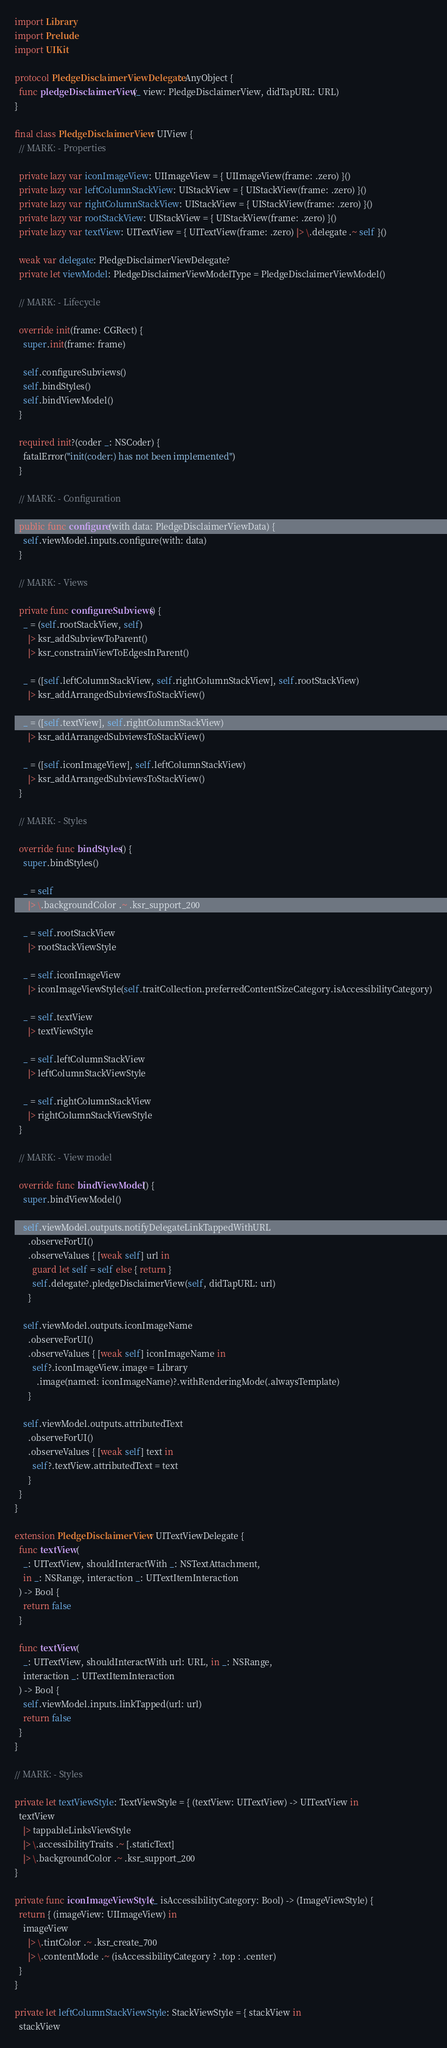<code> <loc_0><loc_0><loc_500><loc_500><_Swift_>import Library
import Prelude
import UIKit

protocol PledgeDisclaimerViewDelegate: AnyObject {
  func pledgeDisclaimerView(_ view: PledgeDisclaimerView, didTapURL: URL)
}

final class PledgeDisclaimerView: UIView {
  // MARK: - Properties

  private lazy var iconImageView: UIImageView = { UIImageView(frame: .zero) }()
  private lazy var leftColumnStackView: UIStackView = { UIStackView(frame: .zero) }()
  private lazy var rightColumnStackView: UIStackView = { UIStackView(frame: .zero) }()
  private lazy var rootStackView: UIStackView = { UIStackView(frame: .zero) }()
  private lazy var textView: UITextView = { UITextView(frame: .zero) |> \.delegate .~ self }()

  weak var delegate: PledgeDisclaimerViewDelegate?
  private let viewModel: PledgeDisclaimerViewModelType = PledgeDisclaimerViewModel()

  // MARK: - Lifecycle

  override init(frame: CGRect) {
    super.init(frame: frame)

    self.configureSubviews()
    self.bindStyles()
    self.bindViewModel()
  }

  required init?(coder _: NSCoder) {
    fatalError("init(coder:) has not been implemented")
  }

  // MARK: - Configuration

  public func configure(with data: PledgeDisclaimerViewData) {
    self.viewModel.inputs.configure(with: data)
  }

  // MARK: - Views

  private func configureSubviews() {
    _ = (self.rootStackView, self)
      |> ksr_addSubviewToParent()
      |> ksr_constrainViewToEdgesInParent()

    _ = ([self.leftColumnStackView, self.rightColumnStackView], self.rootStackView)
      |> ksr_addArrangedSubviewsToStackView()

    _ = ([self.textView], self.rightColumnStackView)
      |> ksr_addArrangedSubviewsToStackView()

    _ = ([self.iconImageView], self.leftColumnStackView)
      |> ksr_addArrangedSubviewsToStackView()
  }

  // MARK: - Styles

  override func bindStyles() {
    super.bindStyles()

    _ = self
      |> \.backgroundColor .~ .ksr_support_200

    _ = self.rootStackView
      |> rootStackViewStyle

    _ = self.iconImageView
      |> iconImageViewStyle(self.traitCollection.preferredContentSizeCategory.isAccessibilityCategory)

    _ = self.textView
      |> textViewStyle

    _ = self.leftColumnStackView
      |> leftColumnStackViewStyle

    _ = self.rightColumnStackView
      |> rightColumnStackViewStyle
  }

  // MARK: - View model

  override func bindViewModel() {
    super.bindViewModel()

    self.viewModel.outputs.notifyDelegateLinkTappedWithURL
      .observeForUI()
      .observeValues { [weak self] url in
        guard let self = self else { return }
        self.delegate?.pledgeDisclaimerView(self, didTapURL: url)
      }

    self.viewModel.outputs.iconImageName
      .observeForUI()
      .observeValues { [weak self] iconImageName in
        self?.iconImageView.image = Library
          .image(named: iconImageName)?.withRenderingMode(.alwaysTemplate)
      }

    self.viewModel.outputs.attributedText
      .observeForUI()
      .observeValues { [weak self] text in
        self?.textView.attributedText = text
      }
  }
}

extension PledgeDisclaimerView: UITextViewDelegate {
  func textView(
    _: UITextView, shouldInteractWith _: NSTextAttachment,
    in _: NSRange, interaction _: UITextItemInteraction
  ) -> Bool {
    return false
  }

  func textView(
    _: UITextView, shouldInteractWith url: URL, in _: NSRange,
    interaction _: UITextItemInteraction
  ) -> Bool {
    self.viewModel.inputs.linkTapped(url: url)
    return false
  }
}

// MARK: - Styles

private let textViewStyle: TextViewStyle = { (textView: UITextView) -> UITextView in
  textView
    |> tappableLinksViewStyle
    |> \.accessibilityTraits .~ [.staticText]
    |> \.backgroundColor .~ .ksr_support_200
}

private func iconImageViewStyle(_ isAccessibilityCategory: Bool) -> (ImageViewStyle) {
  return { (imageView: UIImageView) in
    imageView
      |> \.tintColor .~ .ksr_create_700
      |> \.contentMode .~ (isAccessibilityCategory ? .top : .center)
  }
}

private let leftColumnStackViewStyle: StackViewStyle = { stackView in
  stackView</code> 